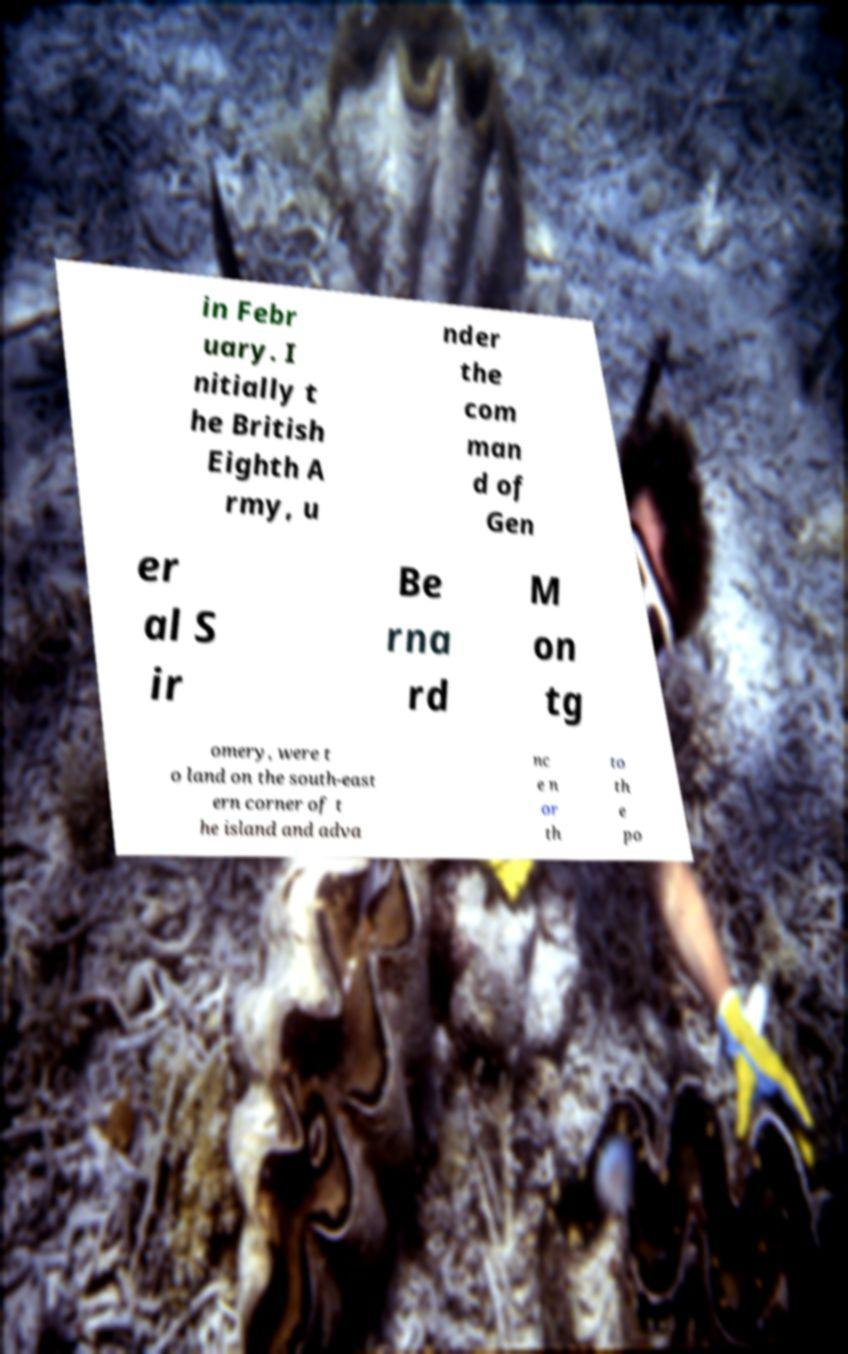Please read and relay the text visible in this image. What does it say? in Febr uary. I nitially t he British Eighth A rmy, u nder the com man d of Gen er al S ir Be rna rd M on tg omery, were t o land on the south-east ern corner of t he island and adva nc e n or th to th e po 